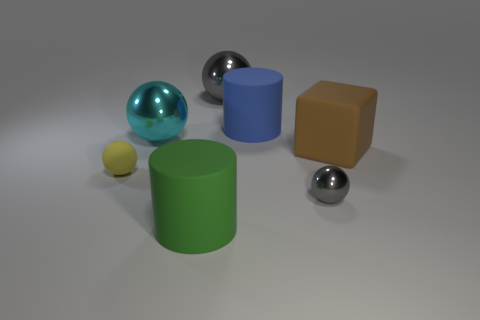How many other objects are the same color as the cube?
Your answer should be compact. 0. Are there more big metallic things behind the large cyan ball than things?
Your answer should be compact. No. Are the cyan sphere and the big brown cube made of the same material?
Keep it short and to the point. No. How many things are either gray metallic spheres that are in front of the tiny rubber ball or large blocks?
Offer a very short reply. 2. What number of other objects are the same size as the green cylinder?
Your response must be concise. 4. Is the number of large rubber cylinders that are on the left side of the large gray metallic object the same as the number of big cyan objects on the right side of the large cube?
Your response must be concise. No. There is another large matte object that is the same shape as the blue thing; what color is it?
Ensure brevity in your answer.  Green. Is there anything else that is the same shape as the cyan thing?
Give a very brief answer. Yes. There is a large shiny ball that is on the right side of the large cyan sphere; does it have the same color as the small metallic ball?
Your response must be concise. Yes. There is another object that is the same shape as the green object; what is its size?
Offer a terse response. Large. 